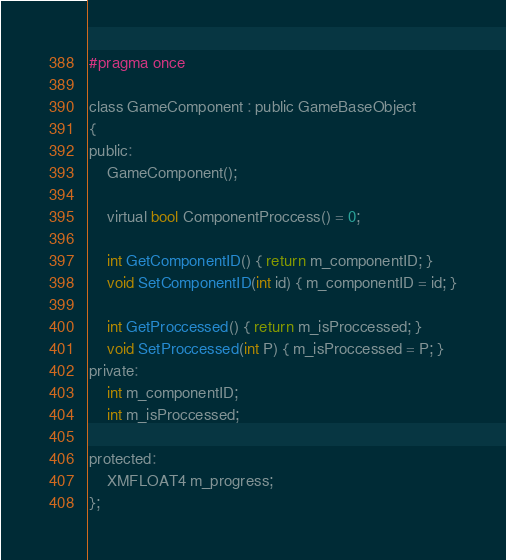<code> <loc_0><loc_0><loc_500><loc_500><_C_>#pragma once

class GameComponent : public GameBaseObject
{
public:
	GameComponent();

	virtual bool ComponentProccess() = 0;

	int GetComponentID() { return m_componentID; }
	void SetComponentID(int id) { m_componentID = id; }

	int GetProccessed() { return m_isProccessed; }
	void SetProccessed(int P) { m_isProccessed = P; }
private:
	int m_componentID;
	int m_isProccessed;

protected:
	XMFLOAT4 m_progress;
};
</code> 